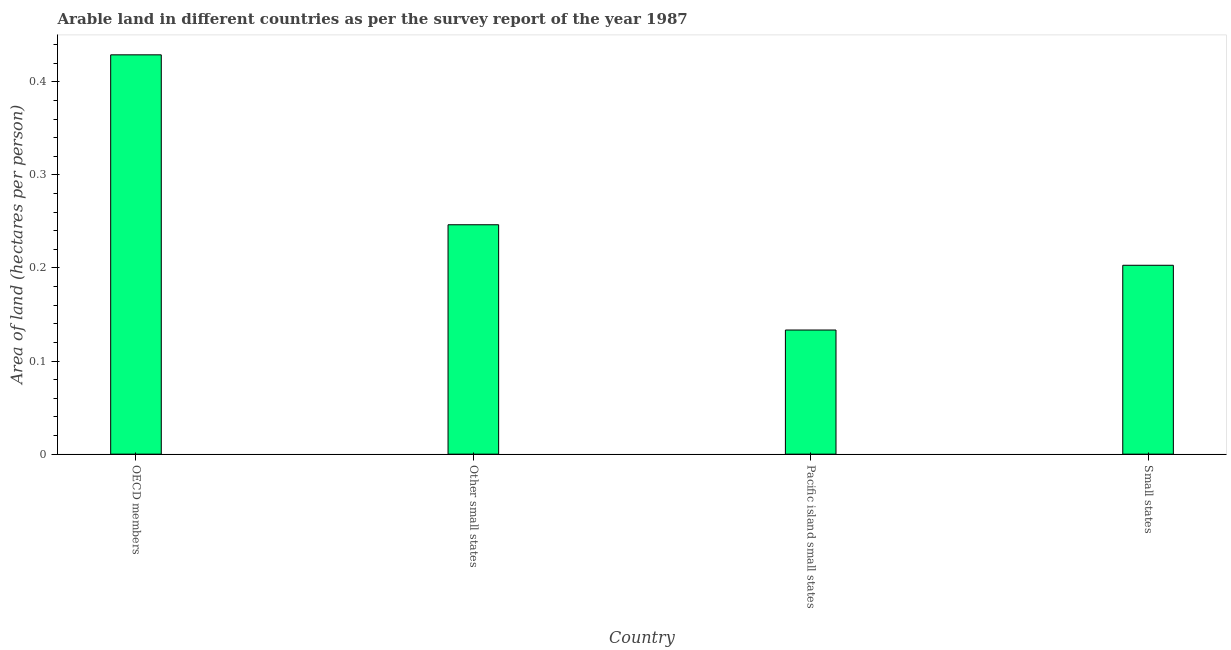Does the graph contain any zero values?
Offer a terse response. No. Does the graph contain grids?
Offer a terse response. No. What is the title of the graph?
Offer a very short reply. Arable land in different countries as per the survey report of the year 1987. What is the label or title of the Y-axis?
Your answer should be very brief. Area of land (hectares per person). What is the area of arable land in Small states?
Ensure brevity in your answer.  0.2. Across all countries, what is the maximum area of arable land?
Offer a terse response. 0.43. Across all countries, what is the minimum area of arable land?
Ensure brevity in your answer.  0.13. In which country was the area of arable land maximum?
Make the answer very short. OECD members. In which country was the area of arable land minimum?
Provide a succinct answer. Pacific island small states. What is the sum of the area of arable land?
Provide a short and direct response. 1.01. What is the difference between the area of arable land in OECD members and Small states?
Make the answer very short. 0.23. What is the average area of arable land per country?
Your answer should be compact. 0.25. What is the median area of arable land?
Your response must be concise. 0.22. What is the ratio of the area of arable land in Pacific island small states to that in Small states?
Your answer should be compact. 0.66. What is the difference between the highest and the second highest area of arable land?
Provide a succinct answer. 0.18. Is the sum of the area of arable land in Other small states and Small states greater than the maximum area of arable land across all countries?
Keep it short and to the point. Yes. In how many countries, is the area of arable land greater than the average area of arable land taken over all countries?
Give a very brief answer. 1. Are all the bars in the graph horizontal?
Offer a terse response. No. How many countries are there in the graph?
Your answer should be compact. 4. What is the difference between two consecutive major ticks on the Y-axis?
Your response must be concise. 0.1. Are the values on the major ticks of Y-axis written in scientific E-notation?
Keep it short and to the point. No. What is the Area of land (hectares per person) in OECD members?
Ensure brevity in your answer.  0.43. What is the Area of land (hectares per person) in Other small states?
Your response must be concise. 0.25. What is the Area of land (hectares per person) in Pacific island small states?
Offer a terse response. 0.13. What is the Area of land (hectares per person) of Small states?
Give a very brief answer. 0.2. What is the difference between the Area of land (hectares per person) in OECD members and Other small states?
Give a very brief answer. 0.18. What is the difference between the Area of land (hectares per person) in OECD members and Pacific island small states?
Provide a succinct answer. 0.3. What is the difference between the Area of land (hectares per person) in OECD members and Small states?
Your answer should be compact. 0.23. What is the difference between the Area of land (hectares per person) in Other small states and Pacific island small states?
Keep it short and to the point. 0.11. What is the difference between the Area of land (hectares per person) in Other small states and Small states?
Provide a short and direct response. 0.04. What is the difference between the Area of land (hectares per person) in Pacific island small states and Small states?
Offer a terse response. -0.07. What is the ratio of the Area of land (hectares per person) in OECD members to that in Other small states?
Keep it short and to the point. 1.74. What is the ratio of the Area of land (hectares per person) in OECD members to that in Pacific island small states?
Your answer should be compact. 3.22. What is the ratio of the Area of land (hectares per person) in OECD members to that in Small states?
Your answer should be compact. 2.11. What is the ratio of the Area of land (hectares per person) in Other small states to that in Pacific island small states?
Offer a very short reply. 1.85. What is the ratio of the Area of land (hectares per person) in Other small states to that in Small states?
Ensure brevity in your answer.  1.21. What is the ratio of the Area of land (hectares per person) in Pacific island small states to that in Small states?
Your answer should be very brief. 0.66. 